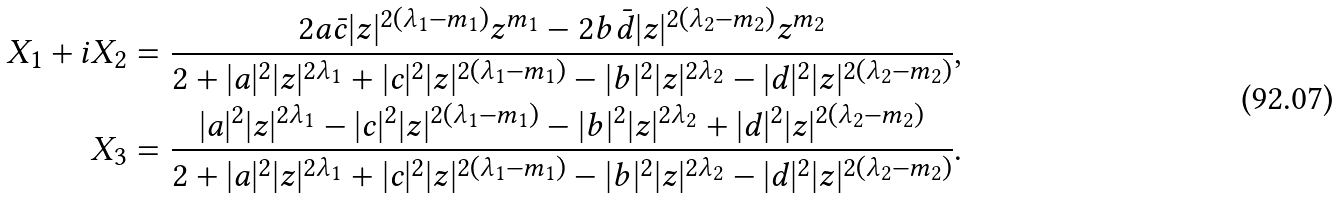Convert formula to latex. <formula><loc_0><loc_0><loc_500><loc_500>X _ { 1 } + i X _ { 2 } & = \frac { 2 a \bar { c } | z | ^ { 2 ( \lambda _ { 1 } - m _ { 1 } ) } z ^ { m _ { 1 } } - 2 b \bar { d } | z | ^ { 2 ( \lambda _ { 2 } - m _ { 2 } ) } z ^ { m _ { 2 } } } { 2 + | a | ^ { 2 } | z | ^ { 2 \lambda _ { 1 } } + | c | ^ { 2 } | z | ^ { 2 ( \lambda _ { 1 } - m _ { 1 } ) } - | b | ^ { 2 } | z | ^ { 2 \lambda _ { 2 } } - | d | ^ { 2 } | z | ^ { 2 ( \lambda _ { 2 } - m _ { 2 } ) } } , \\ X _ { 3 } & = \frac { | a | ^ { 2 } | z | ^ { 2 \lambda _ { 1 } } - | c | ^ { 2 } | z | ^ { 2 ( \lambda _ { 1 } - m _ { 1 } ) } - | b | ^ { 2 } | z | ^ { 2 \lambda _ { 2 } } + | d | ^ { 2 } | z | ^ { 2 ( \lambda _ { 2 } - m _ { 2 } ) } } { 2 + | a | ^ { 2 } | z | ^ { 2 \lambda _ { 1 } } + | c | ^ { 2 } | z | ^ { 2 ( \lambda _ { 1 } - m _ { 1 } ) } - | b | ^ { 2 } | z | ^ { 2 \lambda _ { 2 } } - | d | ^ { 2 } | z | ^ { 2 ( \lambda _ { 2 } - m _ { 2 } ) } } .</formula> 